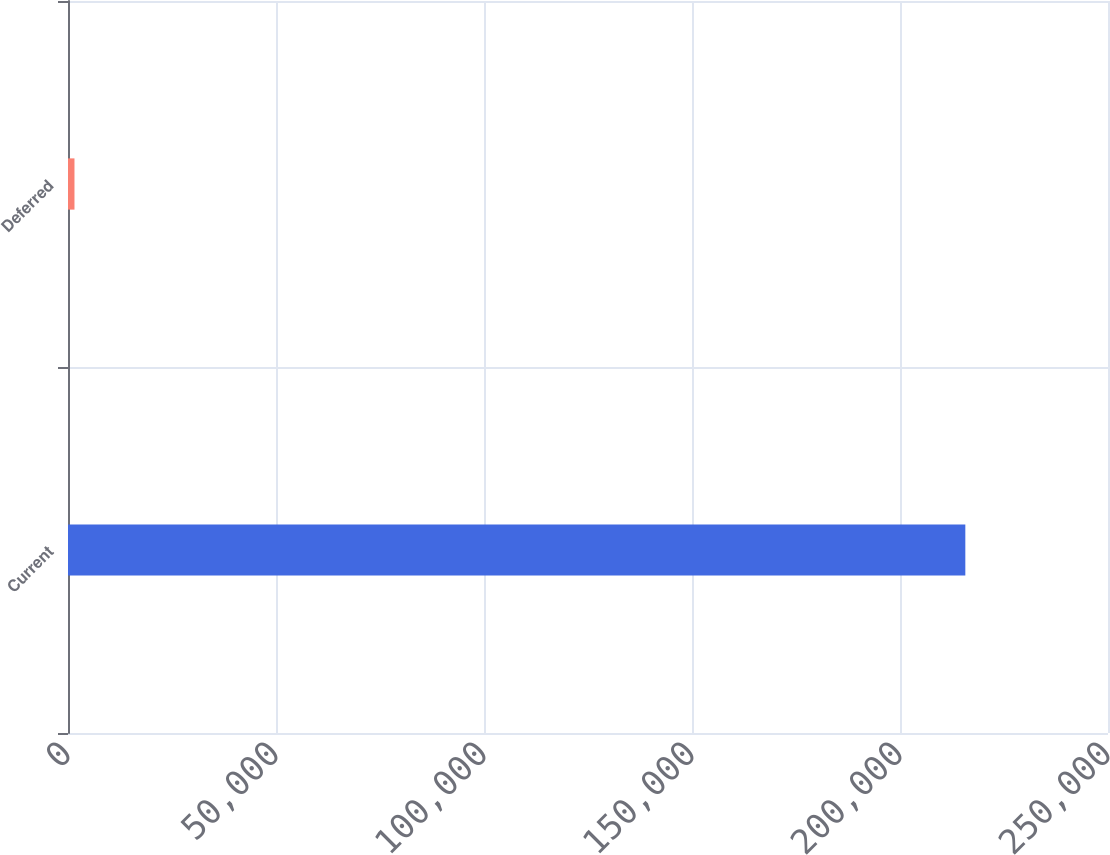Convert chart to OTSL. <chart><loc_0><loc_0><loc_500><loc_500><bar_chart><fcel>Current<fcel>Deferred<nl><fcel>215703<fcel>1559<nl></chart> 